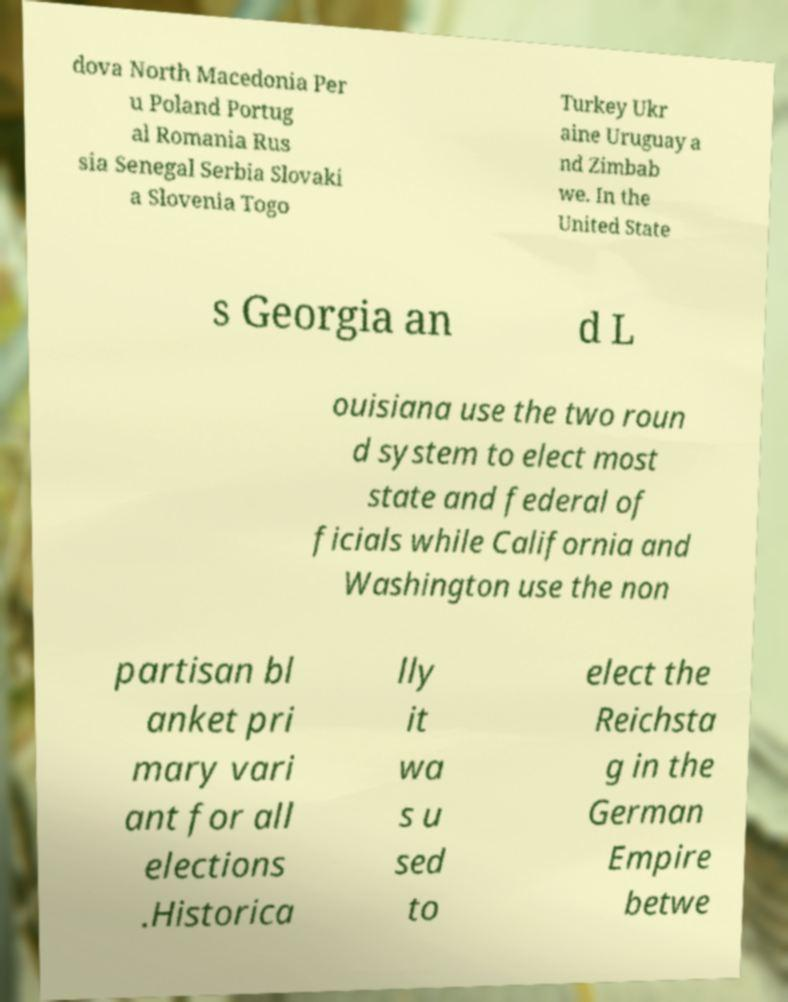Please read and relay the text visible in this image. What does it say? dova North Macedonia Per u Poland Portug al Romania Rus sia Senegal Serbia Slovaki a Slovenia Togo Turkey Ukr aine Uruguay a nd Zimbab we. In the United State s Georgia an d L ouisiana use the two roun d system to elect most state and federal of ficials while California and Washington use the non partisan bl anket pri mary vari ant for all elections .Historica lly it wa s u sed to elect the Reichsta g in the German Empire betwe 